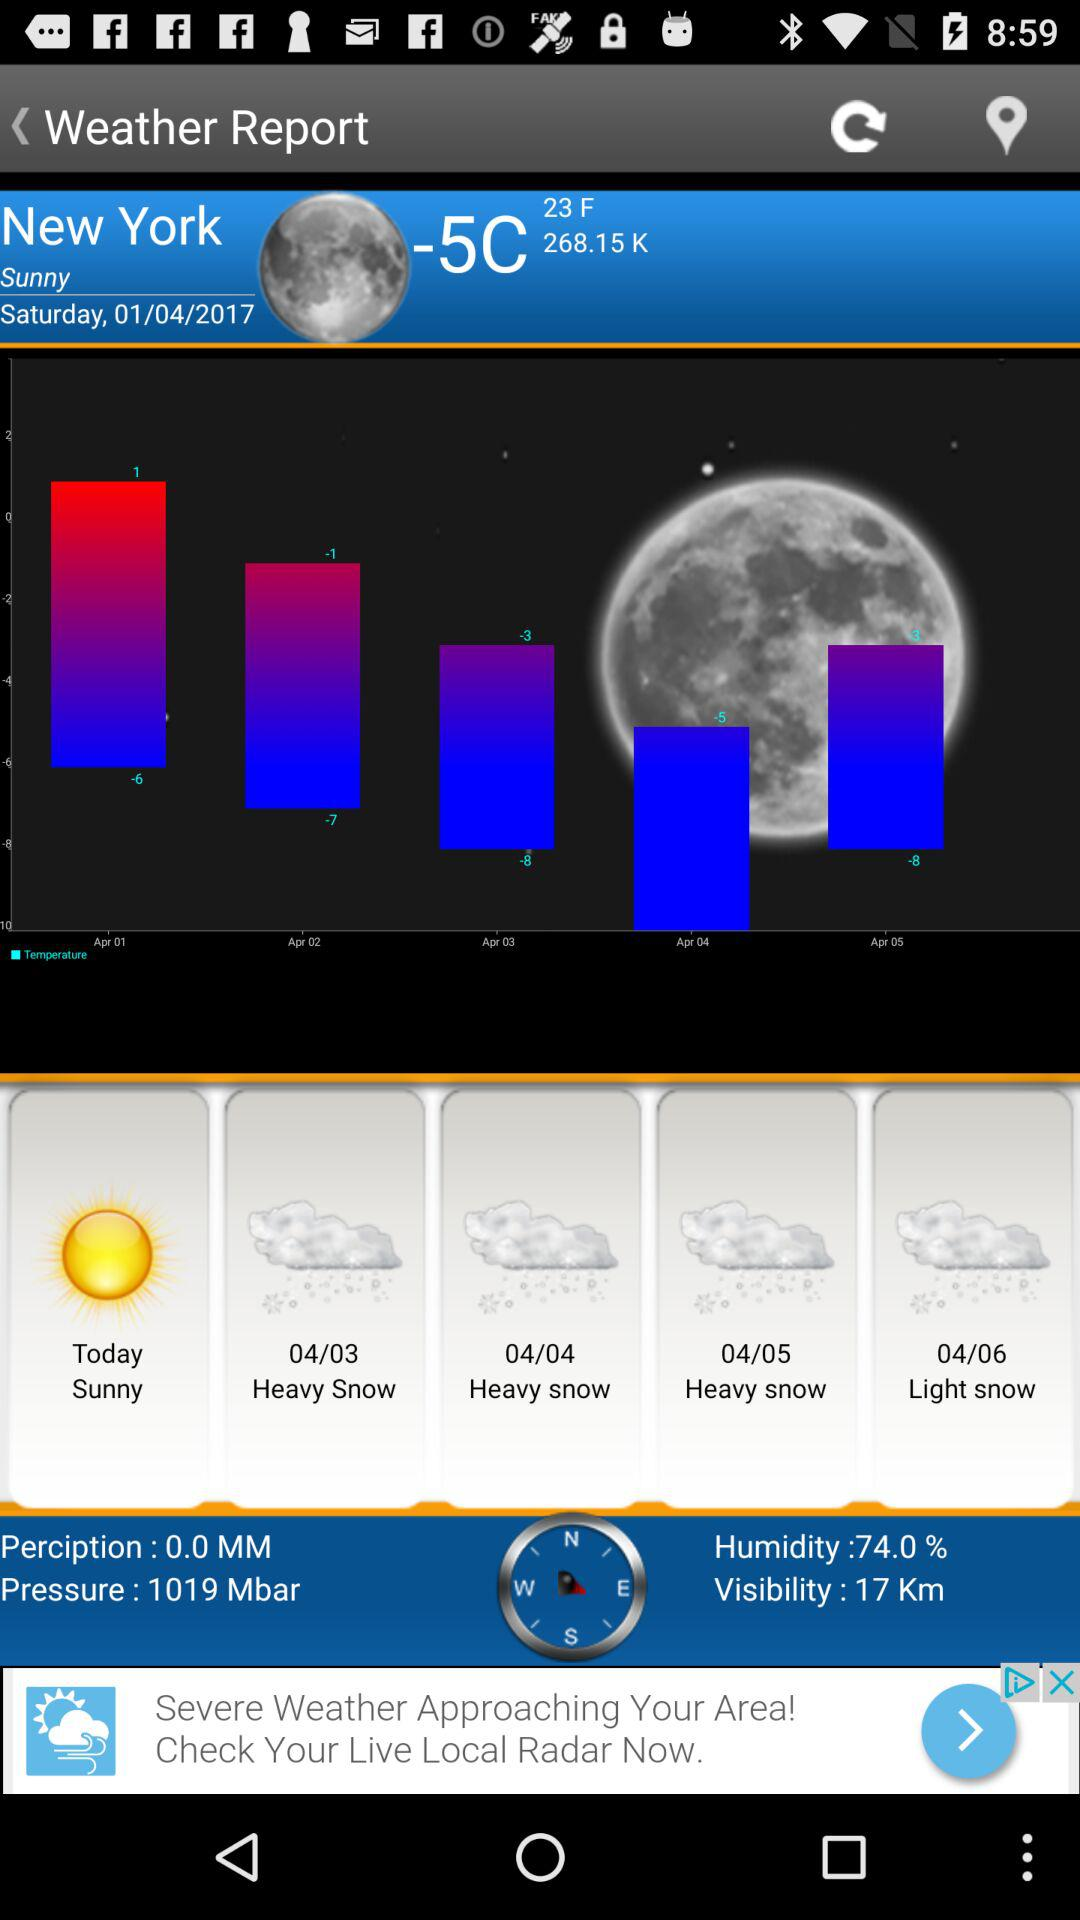What is the weather in New York today? The weather is sunny. 